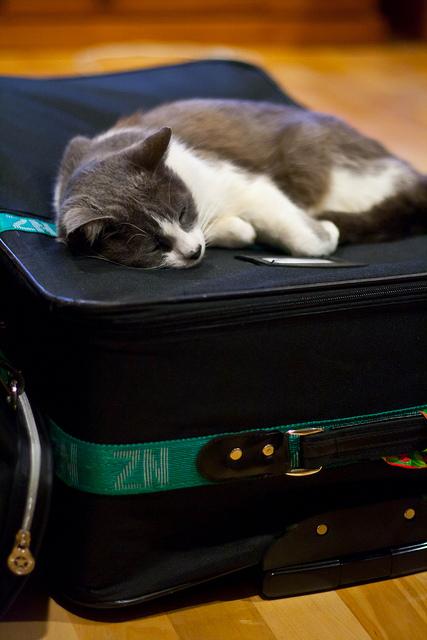What color is the suitcase?
Write a very short answer. Black. What color is the object the cat is laying on?
Give a very brief answer. Black. What is the cat doing?
Answer briefly. Sleeping. Is the suitcase big?
Answer briefly. Yes. Where is the cat?
Answer briefly. On suitcase. What is the cat resting it's head on?
Give a very brief answer. Suitcase. Is the cat happy?
Quick response, please. Yes. 